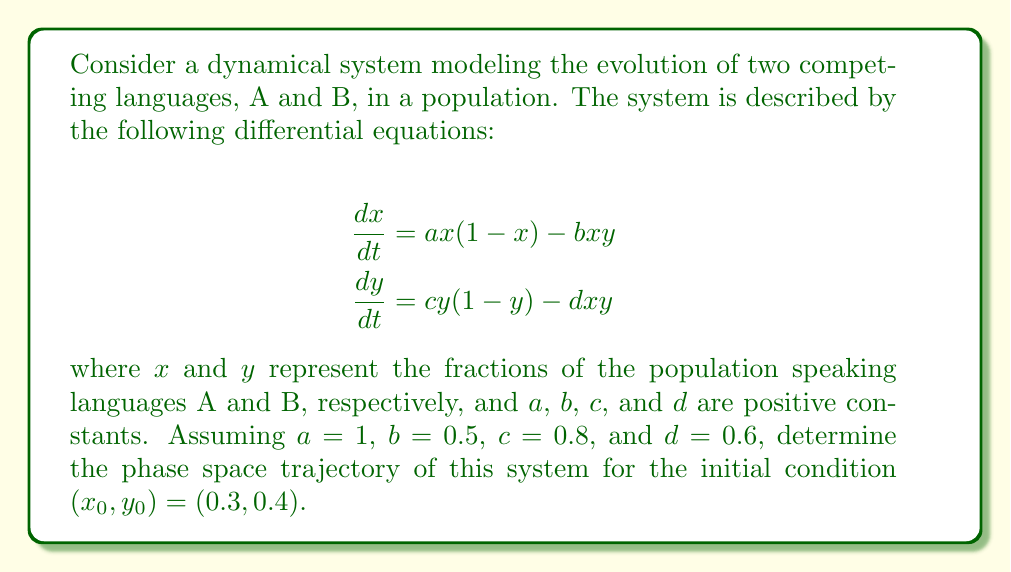Show me your answer to this math problem. To determine the phase space trajectory of this dynamical system, we need to follow these steps:

1) First, we substitute the given values into the differential equations:

   $$\frac{dx}{dt} = x(1-x) - 0.5xy$$
   $$\frac{dy}{dt} = 0.8y(1-y) - 0.6xy$$

2) We can use a numerical method like the Runge-Kutta 4th order method to solve this system of ODEs. However, for the purposes of this explanation, we'll describe the qualitative behavior.

3) The phase space for this system is the unit square $[0,1] \times [0,1]$, as $x$ and $y$ represent fractions of the population.

4) We need to identify the fixed points of the system. These occur where $\frac{dx}{dt} = \frac{dy}{dt} = 0$. Solving these equations, we find four fixed points:
   
   (0,0), (1,0), (0,1), and a coexistence fixed point $(x^*, y^*)$ where both languages survive.

5) The stability of these fixed points can be determined by linearizing the system around each point and analyzing the eigenvalues of the Jacobian matrix.

6) For the given initial condition $(0.3, 0.4)$, the trajectory will evolve towards the stable fixed point, which in this case is likely to be the coexistence fixed point $(x^*, y^*)$.

7) The trajectory will spiral inwards towards this fixed point in the phase space, as the populations of both languages adjust over time.

8) The exact shape of the spiral will depend on the relative strengths of the parameters $a$, $b$, $c$, and $d$, which determine the competition and growth rates of the two languages.

9) As $t \to \infty$, the trajectory will approach the stable fixed point, representing a stable coexistence of the two languages.

To visualize this trajectory accurately, one would need to use numerical methods to solve the differential equations and plot the results in the phase space.
Answer: Spiraling trajectory in $[0,1] \times [0,1]$ converging to stable coexistence fixed point $(x^*, y^*)$. 